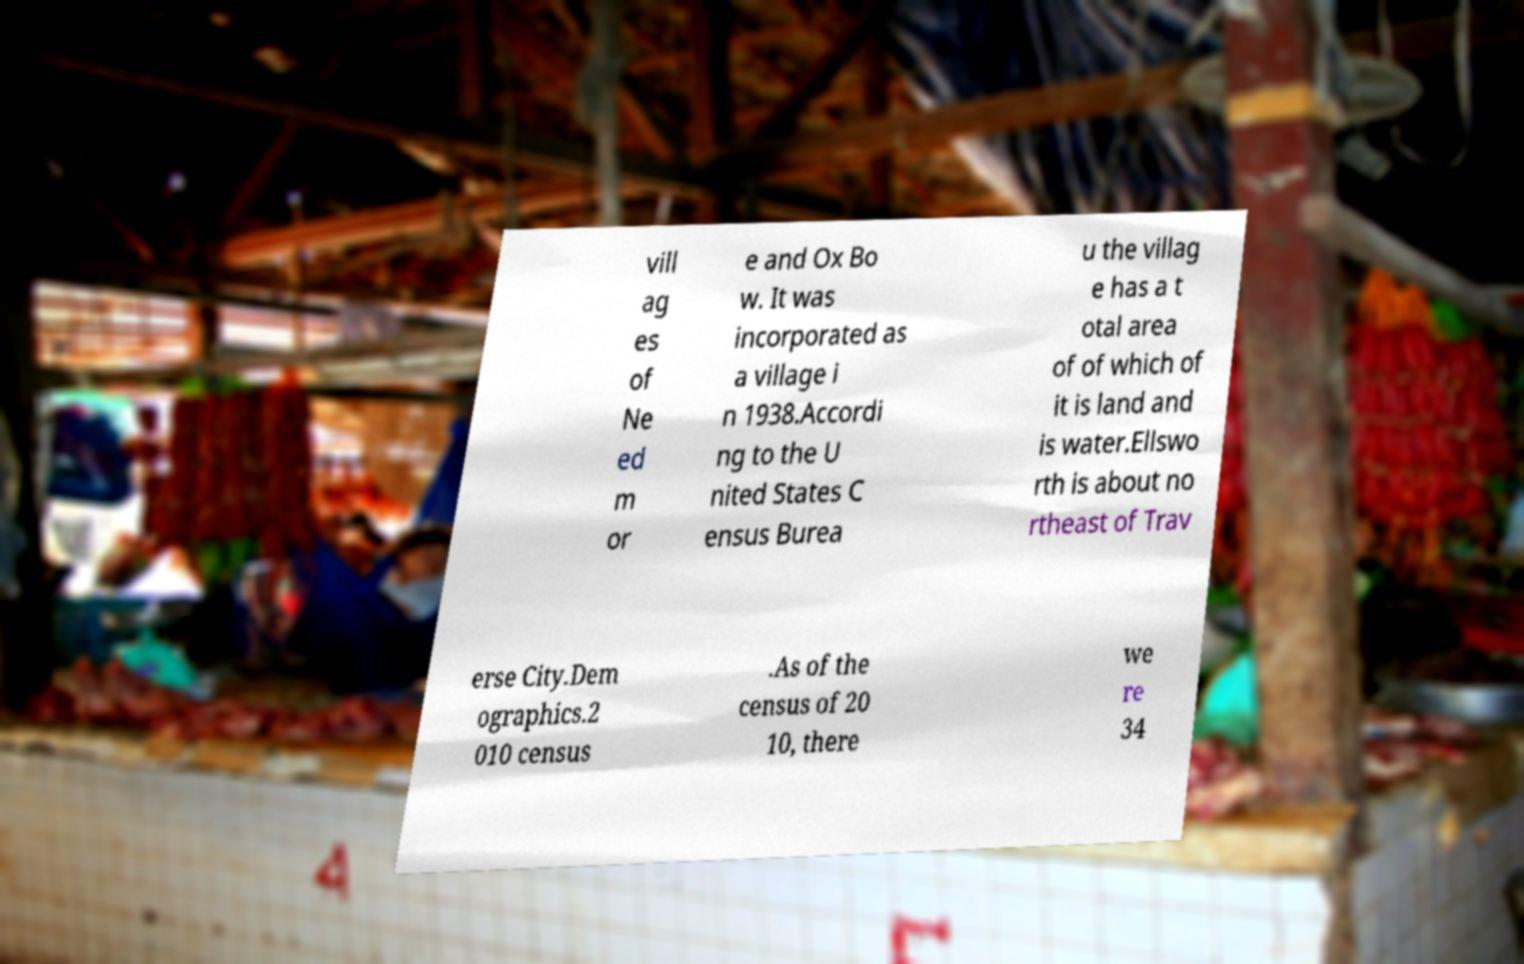What messages or text are displayed in this image? I need them in a readable, typed format. vill ag es of Ne ed m or e and Ox Bo w. It was incorporated as a village i n 1938.Accordi ng to the U nited States C ensus Burea u the villag e has a t otal area of of which of it is land and is water.Ellswo rth is about no rtheast of Trav erse City.Dem ographics.2 010 census .As of the census of 20 10, there we re 34 